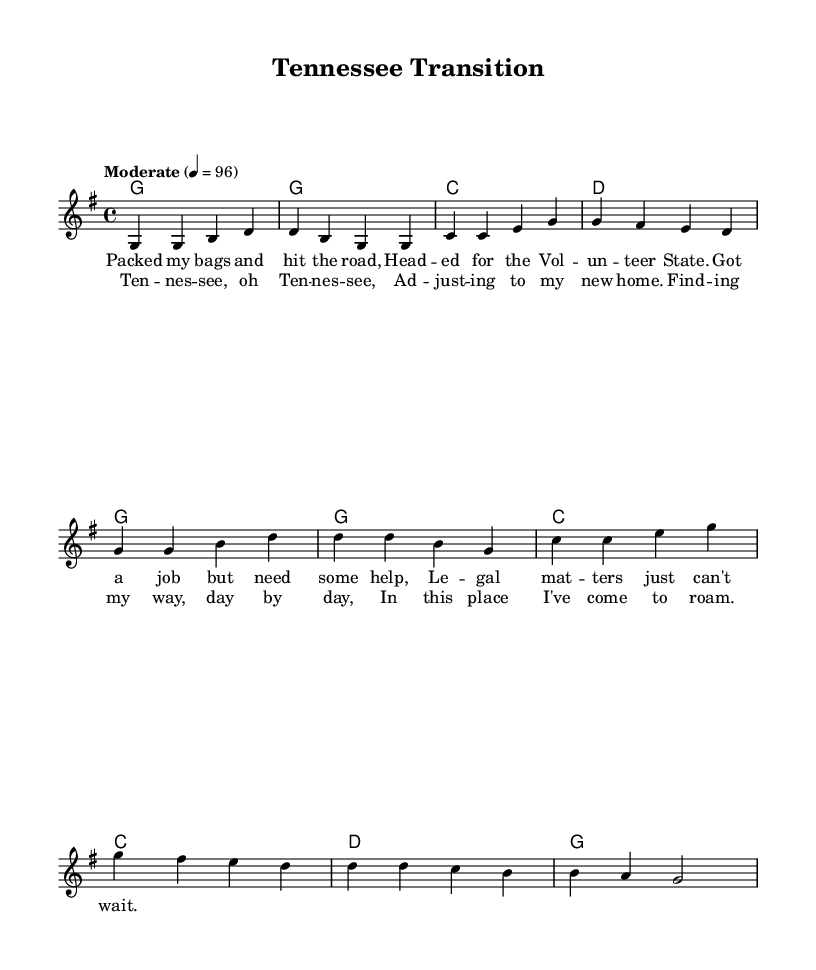What is the key signature of this music? The key signature is G major, which has one sharp (F#). This can be determined by looking at the key signature indicated in the global block of the code.
Answer: G major What is the time signature of this music? The time signature is 4/4, as noted in the global section of the code. This indicates there are four beats in each measure and a quarter note gets one beat.
Answer: 4/4 What is the tempo marking of this piece? The tempo marking is "Moderate" and it is set to 96 beats per minute. This can be seen in the global settings of the code where the tempo is defined.
Answer: Moderate How many measures are in the verse? There are four measures in the verse, as indicated by the melody part where it consists of the four sets of musical notes before changing to the chorus.
Answer: 4 What is the first lyric of the chorus? The first lyric of the chorus is "Tennessee". This can be derived from the lyrics section marked for the chorus part in the code.
Answer: Tennessee How does the chorus relate to the verse in terms of musical structure? The chorus has a similar number of measures as the verse (both consist of four measures), and it builds upon the themes introduced in the verse, indicating a progression in the narrative of adjusting to life in Tennessee. This is seen through the repetitions and variations in the melody and the lyrical themes.
Answer: Similar structure What thematic element is common in both the verse and chorus? The common thematic element is adjusting to a new home, specifically Tennessee. Both the lyrics in the verse mention needing legal assistance in moving, while the chorus expresses the feelings of adapting to the new environment. This thematic consistency solidifies the song's narrative focus.
Answer: Adjusting to a new home 